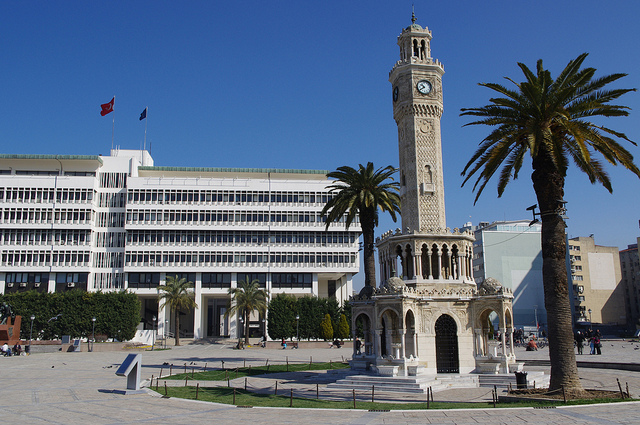<image>How many people are in the building? It is unknowable how many people are actually in the building. The number could be 0 or several hundred. How many people are in the building? I don't know how many people are in the building. It can be any number. 